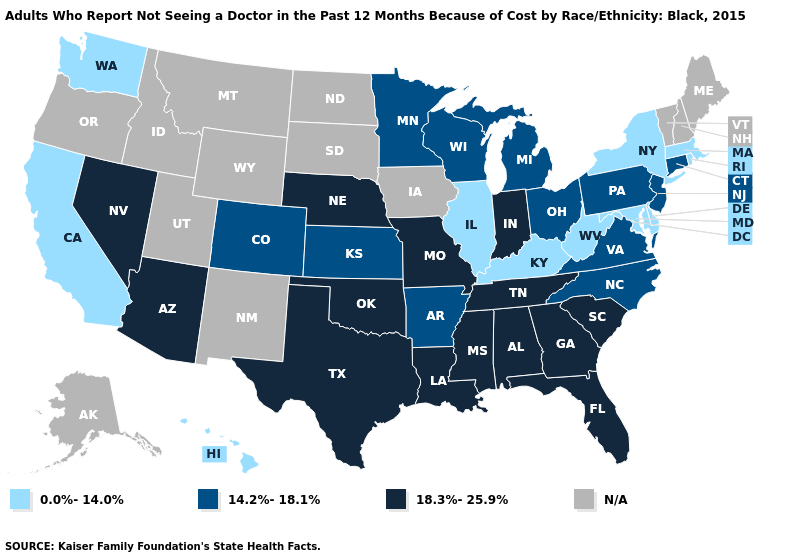Among the states that border Alabama , which have the lowest value?
Write a very short answer. Florida, Georgia, Mississippi, Tennessee. Does Kentucky have the lowest value in the USA?
Concise answer only. Yes. Name the states that have a value in the range 14.2%-18.1%?
Short answer required. Arkansas, Colorado, Connecticut, Kansas, Michigan, Minnesota, New Jersey, North Carolina, Ohio, Pennsylvania, Virginia, Wisconsin. Name the states that have a value in the range 18.3%-25.9%?
Answer briefly. Alabama, Arizona, Florida, Georgia, Indiana, Louisiana, Mississippi, Missouri, Nebraska, Nevada, Oklahoma, South Carolina, Tennessee, Texas. What is the value of Tennessee?
Answer briefly. 18.3%-25.9%. Does Wisconsin have the lowest value in the MidWest?
Be succinct. No. Which states have the lowest value in the USA?
Write a very short answer. California, Delaware, Hawaii, Illinois, Kentucky, Maryland, Massachusetts, New York, Rhode Island, Washington, West Virginia. What is the value of Hawaii?
Give a very brief answer. 0.0%-14.0%. Does the map have missing data?
Answer briefly. Yes. How many symbols are there in the legend?
Answer briefly. 4. Does Nebraska have the highest value in the MidWest?
Keep it brief. Yes. 